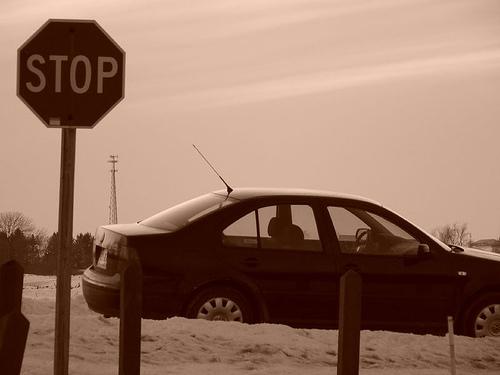Black and white?
Quick response, please. No. What does the sign say?
Short answer required. Stop. How many people does it take to operate this vehicle?
Write a very short answer. 1. 